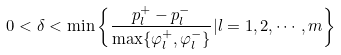<formula> <loc_0><loc_0><loc_500><loc_500>0 < \delta < \min \left \{ \frac { p ^ { + } _ { l } - p ^ { - } _ { l } } { \max \{ \varphi _ { l } ^ { + } , \varphi ^ { - } _ { l } \} } | l = 1 , 2 , \cdots , m \right \}</formula> 